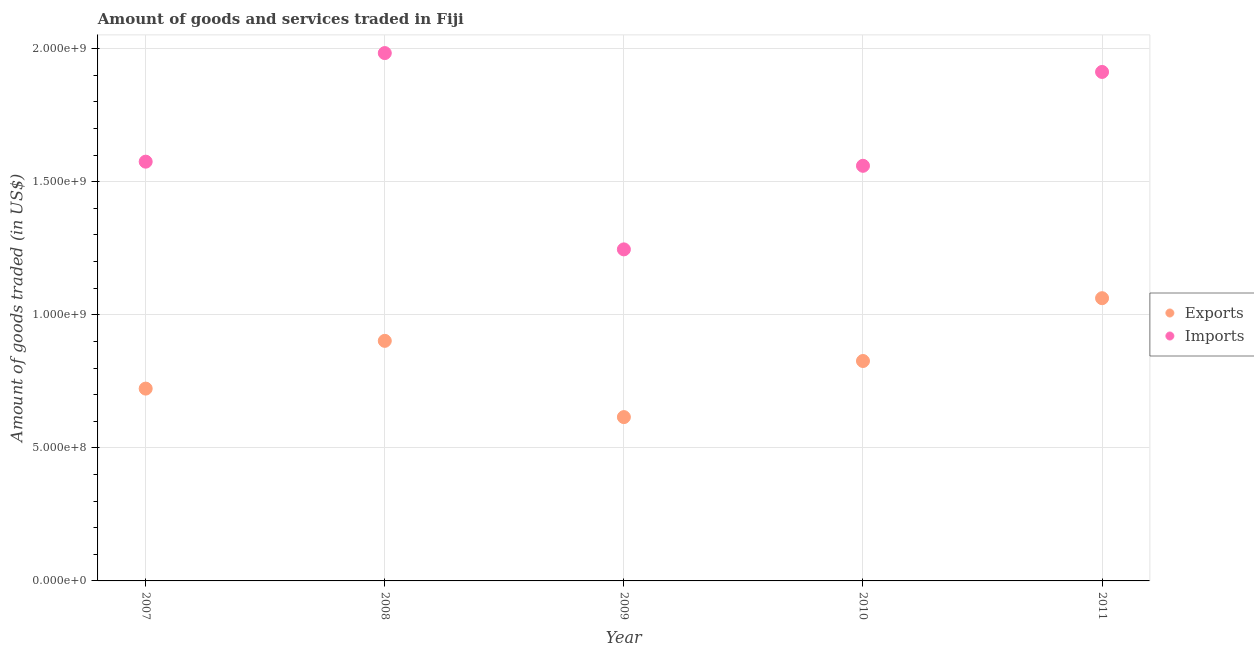How many different coloured dotlines are there?
Give a very brief answer. 2. What is the amount of goods imported in 2011?
Your answer should be very brief. 1.91e+09. Across all years, what is the maximum amount of goods imported?
Offer a terse response. 1.98e+09. Across all years, what is the minimum amount of goods imported?
Ensure brevity in your answer.  1.25e+09. In which year was the amount of goods imported maximum?
Offer a very short reply. 2008. What is the total amount of goods imported in the graph?
Your answer should be compact. 8.28e+09. What is the difference between the amount of goods exported in 2007 and that in 2009?
Your answer should be very brief. 1.07e+08. What is the difference between the amount of goods imported in 2007 and the amount of goods exported in 2008?
Your response must be concise. 6.73e+08. What is the average amount of goods exported per year?
Your response must be concise. 8.26e+08. In the year 2008, what is the difference between the amount of goods exported and amount of goods imported?
Provide a short and direct response. -1.08e+09. What is the ratio of the amount of goods imported in 2007 to that in 2009?
Offer a very short reply. 1.26. What is the difference between the highest and the second highest amount of goods imported?
Your response must be concise. 7.09e+07. What is the difference between the highest and the lowest amount of goods exported?
Make the answer very short. 4.47e+08. How many dotlines are there?
Give a very brief answer. 2. Are the values on the major ticks of Y-axis written in scientific E-notation?
Ensure brevity in your answer.  Yes. Does the graph contain any zero values?
Offer a very short reply. No. Where does the legend appear in the graph?
Keep it short and to the point. Center right. How are the legend labels stacked?
Provide a succinct answer. Vertical. What is the title of the graph?
Keep it short and to the point. Amount of goods and services traded in Fiji. Does "Quality of trade" appear as one of the legend labels in the graph?
Your answer should be very brief. No. What is the label or title of the Y-axis?
Provide a short and direct response. Amount of goods traded (in US$). What is the Amount of goods traded (in US$) of Exports in 2007?
Give a very brief answer. 7.23e+08. What is the Amount of goods traded (in US$) of Imports in 2007?
Give a very brief answer. 1.58e+09. What is the Amount of goods traded (in US$) in Exports in 2008?
Keep it short and to the point. 9.02e+08. What is the Amount of goods traded (in US$) in Imports in 2008?
Keep it short and to the point. 1.98e+09. What is the Amount of goods traded (in US$) of Exports in 2009?
Provide a short and direct response. 6.16e+08. What is the Amount of goods traded (in US$) in Imports in 2009?
Your answer should be compact. 1.25e+09. What is the Amount of goods traded (in US$) in Exports in 2010?
Your answer should be compact. 8.26e+08. What is the Amount of goods traded (in US$) of Imports in 2010?
Keep it short and to the point. 1.56e+09. What is the Amount of goods traded (in US$) of Exports in 2011?
Your answer should be very brief. 1.06e+09. What is the Amount of goods traded (in US$) in Imports in 2011?
Offer a very short reply. 1.91e+09. Across all years, what is the maximum Amount of goods traded (in US$) of Exports?
Ensure brevity in your answer.  1.06e+09. Across all years, what is the maximum Amount of goods traded (in US$) of Imports?
Offer a terse response. 1.98e+09. Across all years, what is the minimum Amount of goods traded (in US$) in Exports?
Offer a terse response. 6.16e+08. Across all years, what is the minimum Amount of goods traded (in US$) of Imports?
Offer a very short reply. 1.25e+09. What is the total Amount of goods traded (in US$) in Exports in the graph?
Your answer should be very brief. 4.13e+09. What is the total Amount of goods traded (in US$) of Imports in the graph?
Your answer should be compact. 8.28e+09. What is the difference between the Amount of goods traded (in US$) of Exports in 2007 and that in 2008?
Ensure brevity in your answer.  -1.79e+08. What is the difference between the Amount of goods traded (in US$) of Imports in 2007 and that in 2008?
Give a very brief answer. -4.08e+08. What is the difference between the Amount of goods traded (in US$) in Exports in 2007 and that in 2009?
Keep it short and to the point. 1.07e+08. What is the difference between the Amount of goods traded (in US$) in Imports in 2007 and that in 2009?
Make the answer very short. 3.30e+08. What is the difference between the Amount of goods traded (in US$) of Exports in 2007 and that in 2010?
Keep it short and to the point. -1.04e+08. What is the difference between the Amount of goods traded (in US$) in Imports in 2007 and that in 2010?
Keep it short and to the point. 1.55e+07. What is the difference between the Amount of goods traded (in US$) of Exports in 2007 and that in 2011?
Keep it short and to the point. -3.40e+08. What is the difference between the Amount of goods traded (in US$) in Imports in 2007 and that in 2011?
Give a very brief answer. -3.37e+08. What is the difference between the Amount of goods traded (in US$) of Exports in 2008 and that in 2009?
Keep it short and to the point. 2.87e+08. What is the difference between the Amount of goods traded (in US$) in Imports in 2008 and that in 2009?
Give a very brief answer. 7.38e+08. What is the difference between the Amount of goods traded (in US$) of Exports in 2008 and that in 2010?
Your answer should be very brief. 7.57e+07. What is the difference between the Amount of goods traded (in US$) in Imports in 2008 and that in 2010?
Your answer should be very brief. 4.24e+08. What is the difference between the Amount of goods traded (in US$) of Exports in 2008 and that in 2011?
Give a very brief answer. -1.60e+08. What is the difference between the Amount of goods traded (in US$) in Imports in 2008 and that in 2011?
Keep it short and to the point. 7.09e+07. What is the difference between the Amount of goods traded (in US$) of Exports in 2009 and that in 2010?
Keep it short and to the point. -2.11e+08. What is the difference between the Amount of goods traded (in US$) of Imports in 2009 and that in 2010?
Offer a very short reply. -3.14e+08. What is the difference between the Amount of goods traded (in US$) of Exports in 2009 and that in 2011?
Ensure brevity in your answer.  -4.47e+08. What is the difference between the Amount of goods traded (in US$) of Imports in 2009 and that in 2011?
Your answer should be compact. -6.67e+08. What is the difference between the Amount of goods traded (in US$) in Exports in 2010 and that in 2011?
Ensure brevity in your answer.  -2.36e+08. What is the difference between the Amount of goods traded (in US$) of Imports in 2010 and that in 2011?
Your answer should be compact. -3.53e+08. What is the difference between the Amount of goods traded (in US$) of Exports in 2007 and the Amount of goods traded (in US$) of Imports in 2008?
Provide a succinct answer. -1.26e+09. What is the difference between the Amount of goods traded (in US$) of Exports in 2007 and the Amount of goods traded (in US$) of Imports in 2009?
Offer a very short reply. -5.23e+08. What is the difference between the Amount of goods traded (in US$) in Exports in 2007 and the Amount of goods traded (in US$) in Imports in 2010?
Your response must be concise. -8.37e+08. What is the difference between the Amount of goods traded (in US$) in Exports in 2007 and the Amount of goods traded (in US$) in Imports in 2011?
Offer a very short reply. -1.19e+09. What is the difference between the Amount of goods traded (in US$) in Exports in 2008 and the Amount of goods traded (in US$) in Imports in 2009?
Ensure brevity in your answer.  -3.44e+08. What is the difference between the Amount of goods traded (in US$) of Exports in 2008 and the Amount of goods traded (in US$) of Imports in 2010?
Offer a very short reply. -6.58e+08. What is the difference between the Amount of goods traded (in US$) of Exports in 2008 and the Amount of goods traded (in US$) of Imports in 2011?
Your response must be concise. -1.01e+09. What is the difference between the Amount of goods traded (in US$) in Exports in 2009 and the Amount of goods traded (in US$) in Imports in 2010?
Make the answer very short. -9.44e+08. What is the difference between the Amount of goods traded (in US$) in Exports in 2009 and the Amount of goods traded (in US$) in Imports in 2011?
Offer a terse response. -1.30e+09. What is the difference between the Amount of goods traded (in US$) of Exports in 2010 and the Amount of goods traded (in US$) of Imports in 2011?
Give a very brief answer. -1.09e+09. What is the average Amount of goods traded (in US$) in Exports per year?
Offer a terse response. 8.26e+08. What is the average Amount of goods traded (in US$) of Imports per year?
Provide a succinct answer. 1.66e+09. In the year 2007, what is the difference between the Amount of goods traded (in US$) in Exports and Amount of goods traded (in US$) in Imports?
Make the answer very short. -8.53e+08. In the year 2008, what is the difference between the Amount of goods traded (in US$) in Exports and Amount of goods traded (in US$) in Imports?
Your answer should be compact. -1.08e+09. In the year 2009, what is the difference between the Amount of goods traded (in US$) of Exports and Amount of goods traded (in US$) of Imports?
Offer a very short reply. -6.30e+08. In the year 2010, what is the difference between the Amount of goods traded (in US$) in Exports and Amount of goods traded (in US$) in Imports?
Provide a succinct answer. -7.34e+08. In the year 2011, what is the difference between the Amount of goods traded (in US$) in Exports and Amount of goods traded (in US$) in Imports?
Your response must be concise. -8.50e+08. What is the ratio of the Amount of goods traded (in US$) in Exports in 2007 to that in 2008?
Offer a terse response. 0.8. What is the ratio of the Amount of goods traded (in US$) in Imports in 2007 to that in 2008?
Offer a very short reply. 0.79. What is the ratio of the Amount of goods traded (in US$) of Exports in 2007 to that in 2009?
Your answer should be very brief. 1.17. What is the ratio of the Amount of goods traded (in US$) in Imports in 2007 to that in 2009?
Make the answer very short. 1.26. What is the ratio of the Amount of goods traded (in US$) in Exports in 2007 to that in 2010?
Offer a terse response. 0.87. What is the ratio of the Amount of goods traded (in US$) in Imports in 2007 to that in 2010?
Provide a short and direct response. 1.01. What is the ratio of the Amount of goods traded (in US$) of Exports in 2007 to that in 2011?
Your answer should be compact. 0.68. What is the ratio of the Amount of goods traded (in US$) of Imports in 2007 to that in 2011?
Ensure brevity in your answer.  0.82. What is the ratio of the Amount of goods traded (in US$) in Exports in 2008 to that in 2009?
Offer a terse response. 1.47. What is the ratio of the Amount of goods traded (in US$) in Imports in 2008 to that in 2009?
Offer a terse response. 1.59. What is the ratio of the Amount of goods traded (in US$) in Exports in 2008 to that in 2010?
Keep it short and to the point. 1.09. What is the ratio of the Amount of goods traded (in US$) of Imports in 2008 to that in 2010?
Provide a succinct answer. 1.27. What is the ratio of the Amount of goods traded (in US$) of Exports in 2008 to that in 2011?
Offer a very short reply. 0.85. What is the ratio of the Amount of goods traded (in US$) in Imports in 2008 to that in 2011?
Your answer should be very brief. 1.04. What is the ratio of the Amount of goods traded (in US$) in Exports in 2009 to that in 2010?
Ensure brevity in your answer.  0.74. What is the ratio of the Amount of goods traded (in US$) in Imports in 2009 to that in 2010?
Provide a short and direct response. 0.8. What is the ratio of the Amount of goods traded (in US$) of Exports in 2009 to that in 2011?
Your response must be concise. 0.58. What is the ratio of the Amount of goods traded (in US$) of Imports in 2009 to that in 2011?
Make the answer very short. 0.65. What is the ratio of the Amount of goods traded (in US$) in Exports in 2010 to that in 2011?
Ensure brevity in your answer.  0.78. What is the ratio of the Amount of goods traded (in US$) of Imports in 2010 to that in 2011?
Your response must be concise. 0.82. What is the difference between the highest and the second highest Amount of goods traded (in US$) in Exports?
Your answer should be very brief. 1.60e+08. What is the difference between the highest and the second highest Amount of goods traded (in US$) of Imports?
Offer a very short reply. 7.09e+07. What is the difference between the highest and the lowest Amount of goods traded (in US$) in Exports?
Your response must be concise. 4.47e+08. What is the difference between the highest and the lowest Amount of goods traded (in US$) of Imports?
Offer a terse response. 7.38e+08. 